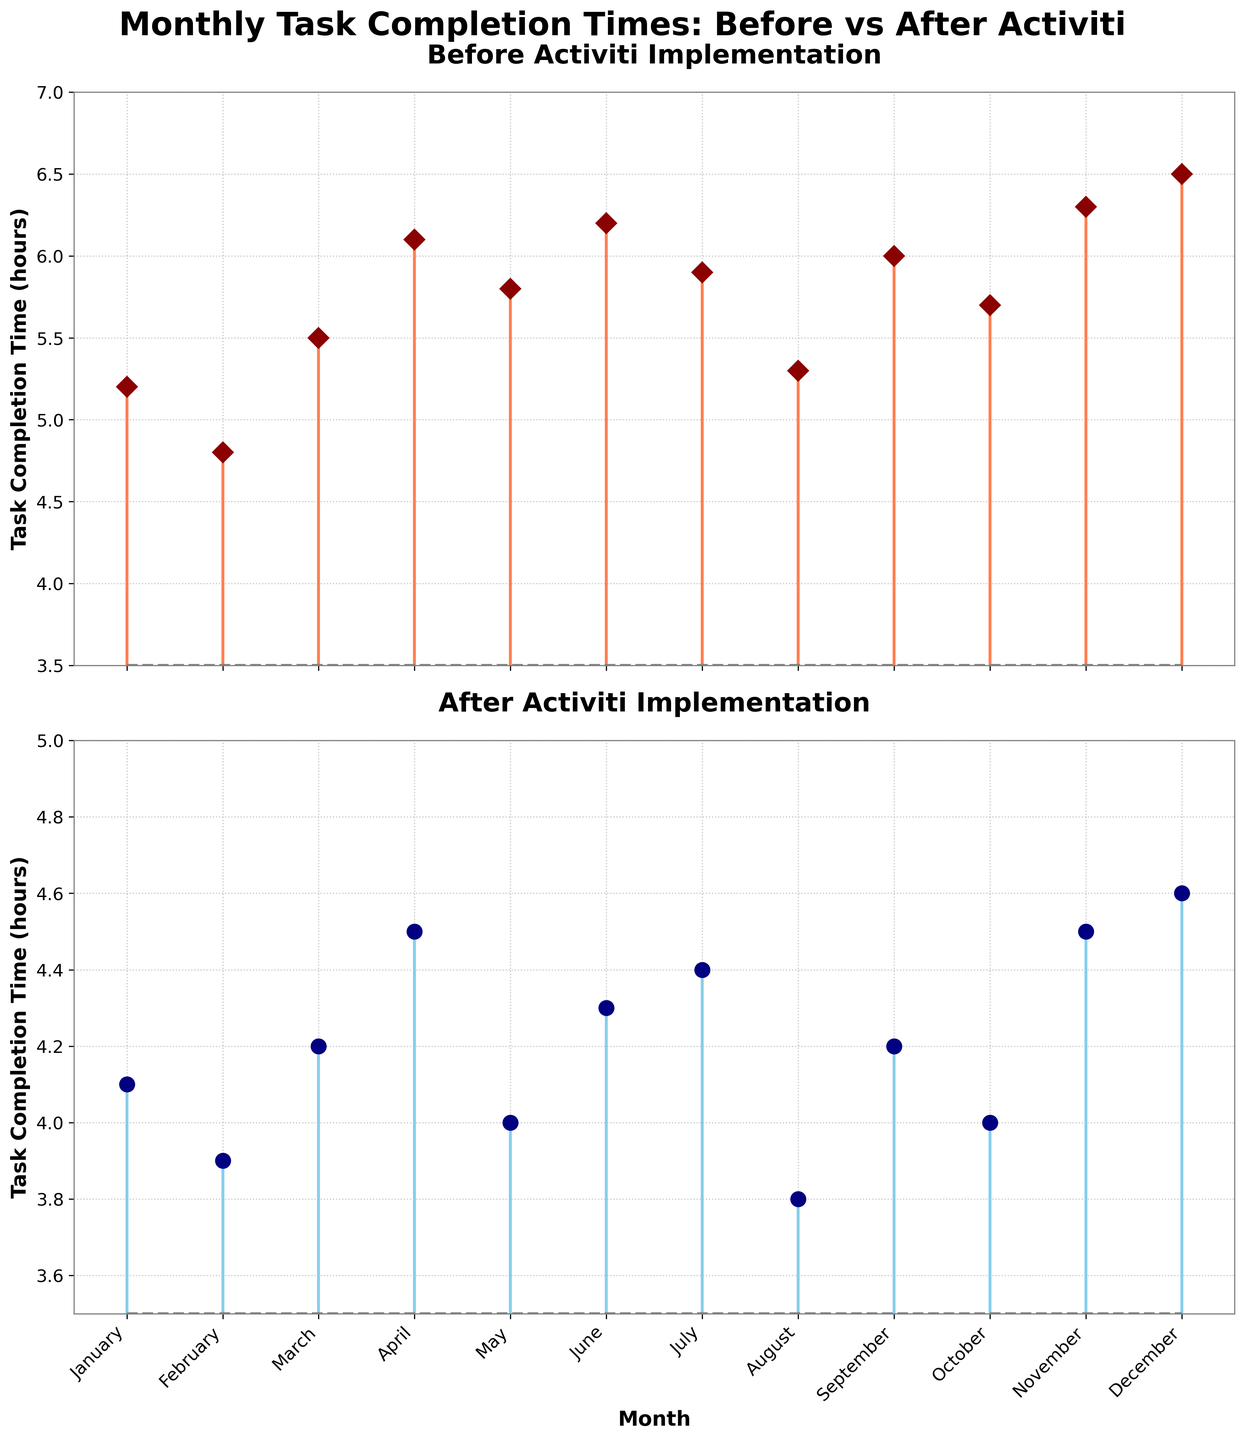What's the title of the figure? The title of the figure is located at the top and is written in large, bold font. It reads: 'Monthly Task Completion Times: Before vs After Activiti'
Answer: Monthly Task Completion Times: Before vs After Activiti What are the y-axis labels for both subplots? The y-axis labels for both subplots can be found vertically along the left side of each subplot. For both, it reads: 'Task Completion Time (hours)'
Answer: Task Completion Time (hours) How many months are displayed in the figure? The number of months can be counted along the x-axis where each month is marked. By counting them, you see there are 12 months.
Answer: 12 months Which month had the highest task completion time before implementing Activiti? To find the highest task completion time before implementing Activiti, compare all the values in the first subplot. December has the highest value at 6.5 hours.
Answer: December What is the task completion time in April after implementing Activiti? To find this, locate April on the x-axis of the second subplot and read the corresponding stem plot value. It is marked at 4.5 hours.
Answer: 4.5 hours What is the difference in task completion time between June before and after implementing Activiti? For June, the task completion time before Activiti is 6.2 hours, and after Activiti is 4.3 hours. Subtracting these values gives 6.2 - 4.3 = 1.9 hours.
Answer: 1.9 hours Which month showed the greatest improvement in task completion time after implementing Activiti? To find the greatest improvement, calculate the difference for each month and identify the largest one. August showed the greatest improvement, decreasing from 5.3 to 3.8 hours, an improvement of 1.5 hours.
Answer: August What is the average task completion time for the year before implementing Activiti? Add all the values before implementing Activiti and divide by the number of months (12). (5.2 + 4.8 + 5.5 + 6.1 + 5.8 + 6.2 + 5.9 + 5.3 + 6.0 + 5.7 + 6.3 + 6.5) / 12 = 5.7667
Answer: 5.77 hours How does the range of task completion times compare before and after implementing Activiti? The range is the difference between the highest and lowest values. Before implementation: 6.5 - 4.8 = 2.7. After implementation: 4.6 - 3.8 = 0.8. The range before is larger.
Answer: The range before implementation is larger What visual features help to distinguish the two subplots? The two subplots are distinguished by different colors and markers: the first plot uses coral lines and diamond markers, while the second uses skyblue lines and circle markers.
Answer: Different colors and markers 